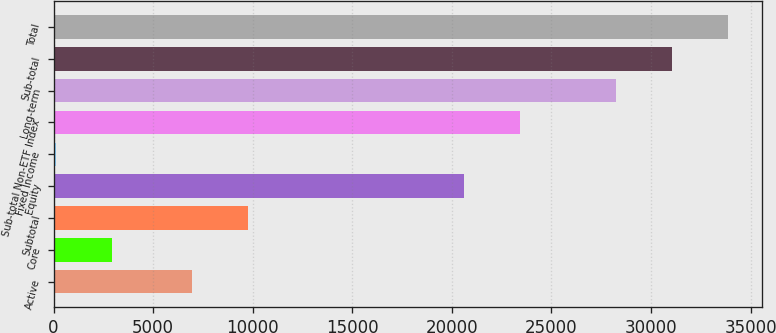<chart> <loc_0><loc_0><loc_500><loc_500><bar_chart><fcel>Active<fcel>Core<fcel>Subtotal<fcel>Equity<fcel>Fixed Income<fcel>Sub-total Non-ETF Index<fcel>Long-term<fcel>Sub-total<fcel>Total<nl><fcel>6943<fcel>2926.8<fcel>9756.8<fcel>20630<fcel>113<fcel>23443.8<fcel>28251<fcel>31064.8<fcel>33878.6<nl></chart> 